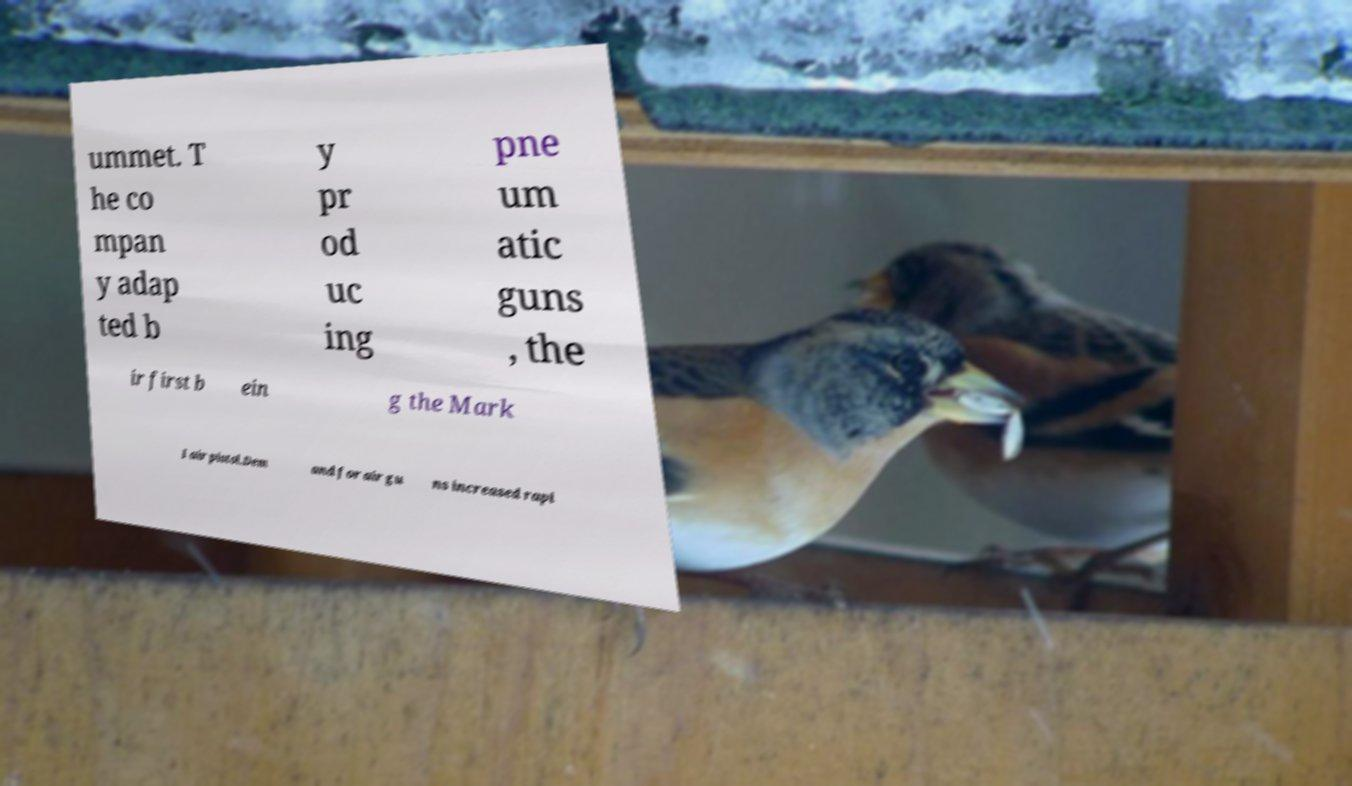What messages or text are displayed in this image? I need them in a readable, typed format. ummet. T he co mpan y adap ted b y pr od uc ing pne um atic guns , the ir first b ein g the Mark I air pistol.Dem and for air gu ns increased rapi 